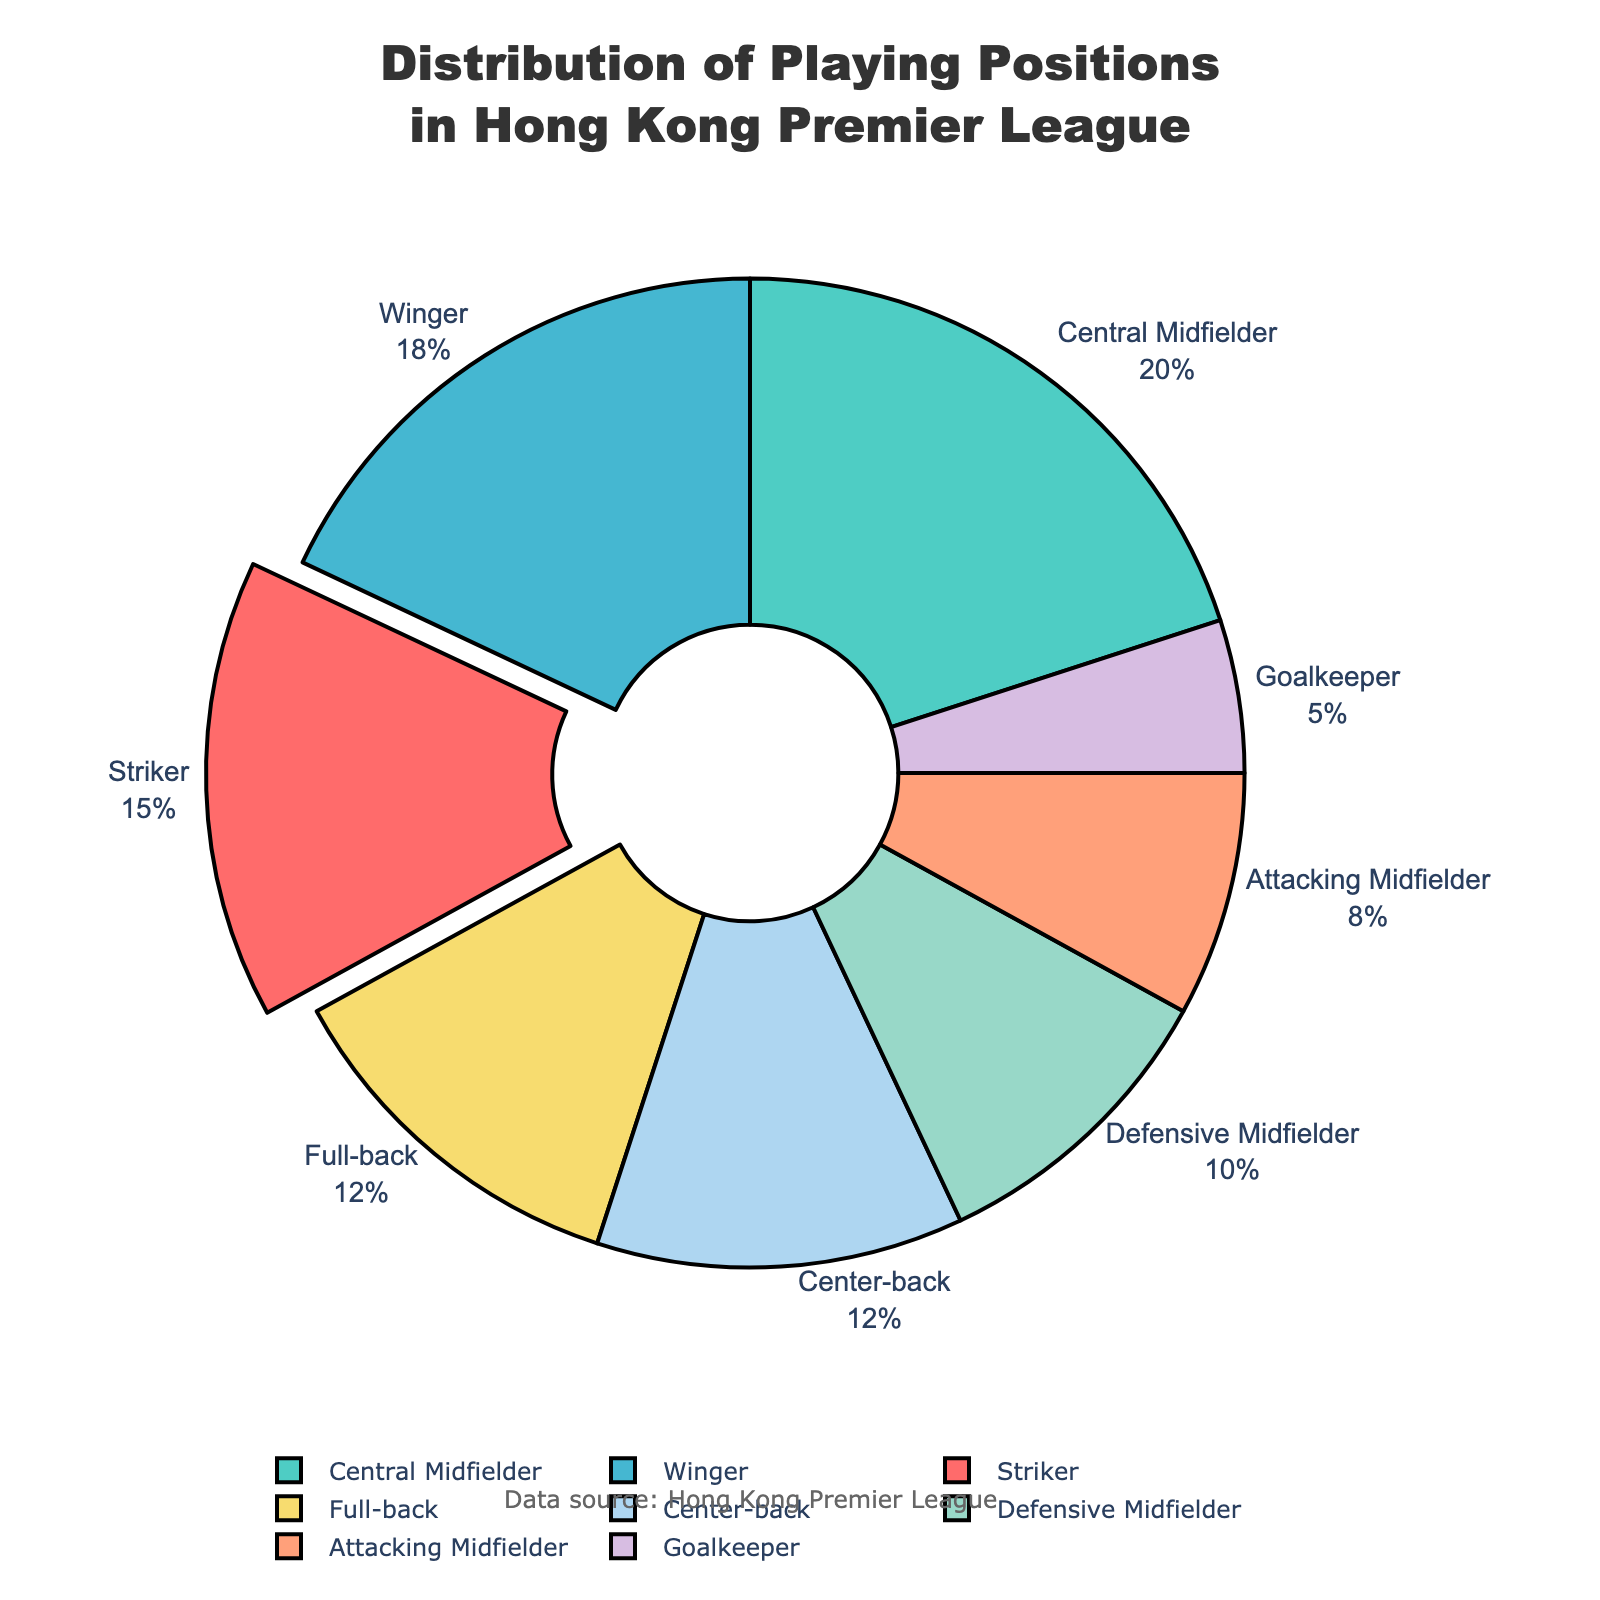What is the most common playing position in the Hong Kong Premier League? The pie chart shows the largest segment labeled as 'Central Midfielder' with 20%. Therefore, the most common playing position is Central Midfielder.
Answer: Central Midfielder What percentage of players are either Central Midfielders or Wingers? The pie chart shows Central Midfielders at 20% and Wingers at 18%. Adding these together gives 20% + 18% = 38%.
Answer: 38% Which position has the lowest percentage of players? The smallest segment in the pie chart is labeled 'Goalkeeper', representing 5%. Therefore, Goalkeeper has the lowest percentage of players.
Answer: Goalkeeper Are there more Central Midfielders or Full-backs? The pie chart shows Central Midfielders at 20% and Full-backs at 12%. Since 20% is greater than 12%, there are more Central Midfielders.
Answer: Central Midfielders How much larger is the percentage of Central Midfielders compared to Strikers? The pie chart shows Central Midfielders at 20% and Strikers at 15%. The difference is 20% - 15% = 5%.
Answer: 5% What is the combined percentage of Defenders (Full-backs and Center-backs)? The pie chart shows Full-backs at 12% and Center-backs at 12%. Adding these together gives 12% + 12% = 24%.
Answer: 24% Which positions together make up half of the total distribution? Adding the top percentages: Central Midfielders (20%), Wingers (18%), and Strikers (15%). Central Midfielders + Wingers + Strikers = 20% + 18% + 15% = 53%. These three positions comprise slightly more than half.
Answer: Central Midfielders, Wingers, Strikers What percentage of players are in mid-field roles (Central, Attacking, and Defensive Midfielder)? The pie chart shows Central Midfielders at 20%, Attacking Midfielders at 8%, and Defensive Midfielders at 10%. Summing these, we get 20% + 8% + 10% = 38%.
Answer: 38% Which position is more common: Winger or Full-back? The pie chart shows Wingers at 18% and Full-backs at 12%. Since 18% is greater than 12%, Winger is more common.
Answer: Winger 